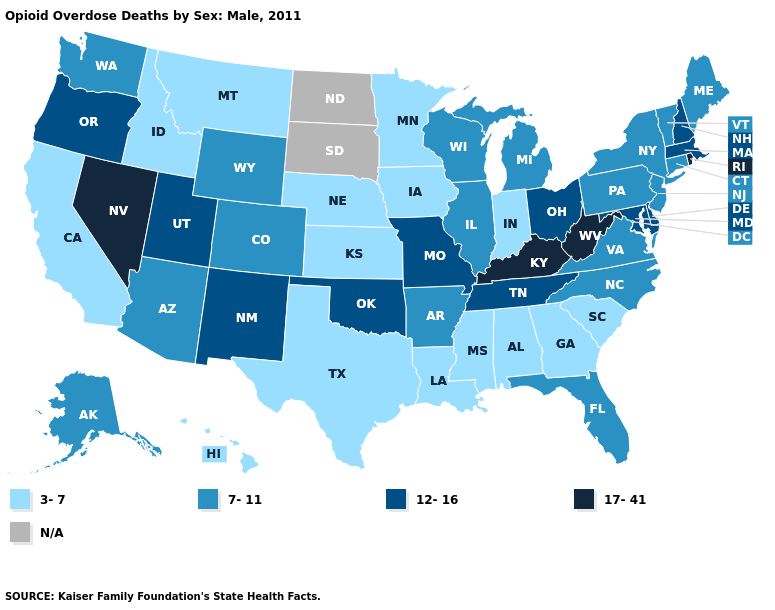What is the lowest value in the USA?
Write a very short answer. 3-7. What is the value of Utah?
Give a very brief answer. 12-16. Name the states that have a value in the range 17-41?
Short answer required. Kentucky, Nevada, Rhode Island, West Virginia. Name the states that have a value in the range 7-11?
Short answer required. Alaska, Arizona, Arkansas, Colorado, Connecticut, Florida, Illinois, Maine, Michigan, New Jersey, New York, North Carolina, Pennsylvania, Vermont, Virginia, Washington, Wisconsin, Wyoming. What is the value of Nebraska?
Be succinct. 3-7. Does Kentucky have the highest value in the USA?
Answer briefly. Yes. Does Kentucky have the highest value in the USA?
Concise answer only. Yes. Does West Virginia have the highest value in the South?
Be succinct. Yes. Name the states that have a value in the range 17-41?
Short answer required. Kentucky, Nevada, Rhode Island, West Virginia. What is the highest value in the Northeast ?
Concise answer only. 17-41. What is the value of Wisconsin?
Write a very short answer. 7-11. What is the value of Georgia?
Be succinct. 3-7. 